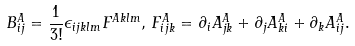Convert formula to latex. <formula><loc_0><loc_0><loc_500><loc_500>B ^ { A } _ { i j } = \frac { 1 } { 3 ! } \epsilon _ { i j k l m } F ^ { A k l m } , \, F ^ { A } _ { i j k } = \partial _ { i } A ^ { A } _ { j k } + \partial _ { j } A ^ { A } _ { k i } + \partial _ { k } A ^ { A } _ { i j } .</formula> 